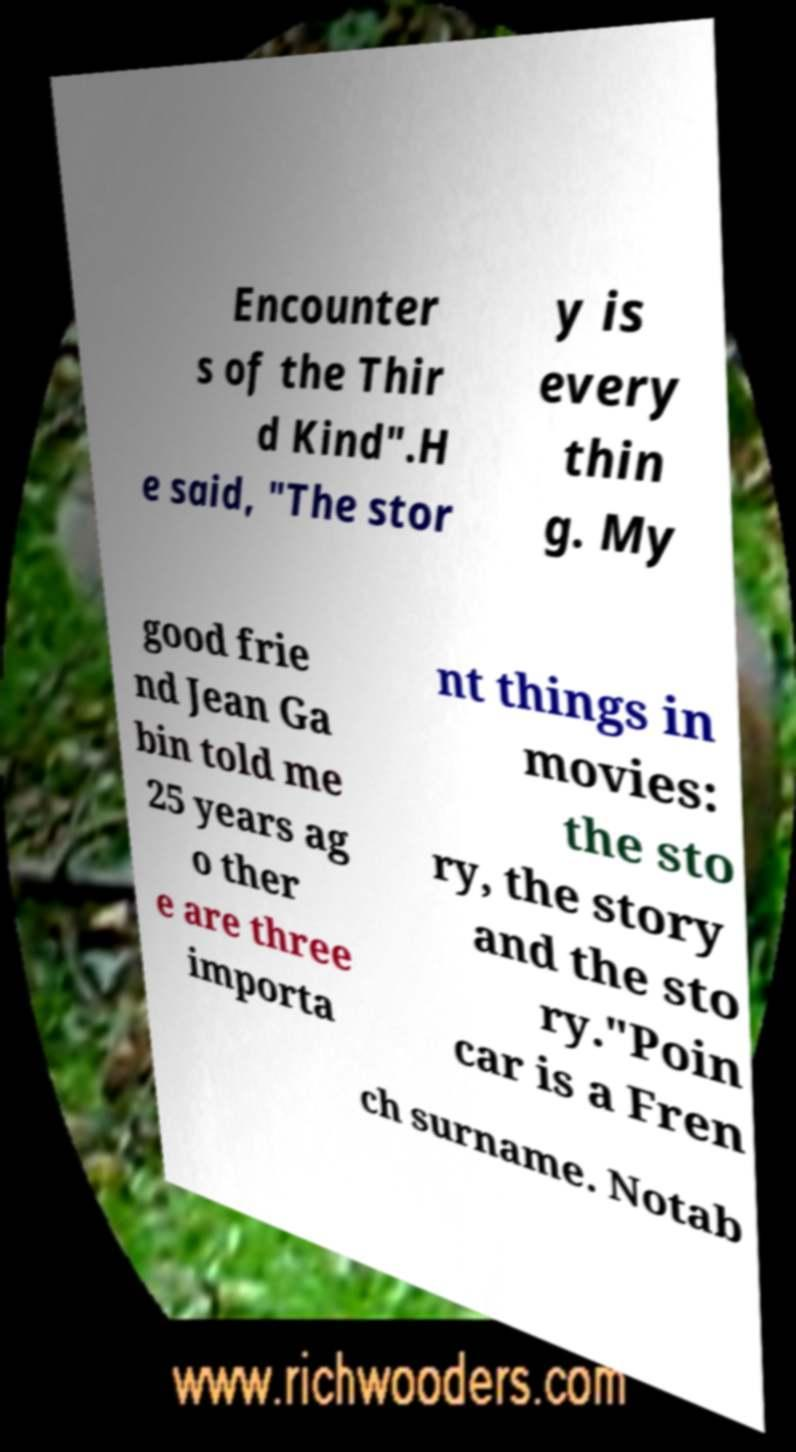Could you assist in decoding the text presented in this image and type it out clearly? Encounter s of the Thir d Kind".H e said, "The stor y is every thin g. My good frie nd Jean Ga bin told me 25 years ag o ther e are three importa nt things in movies: the sto ry, the story and the sto ry."Poin car is a Fren ch surname. Notab 